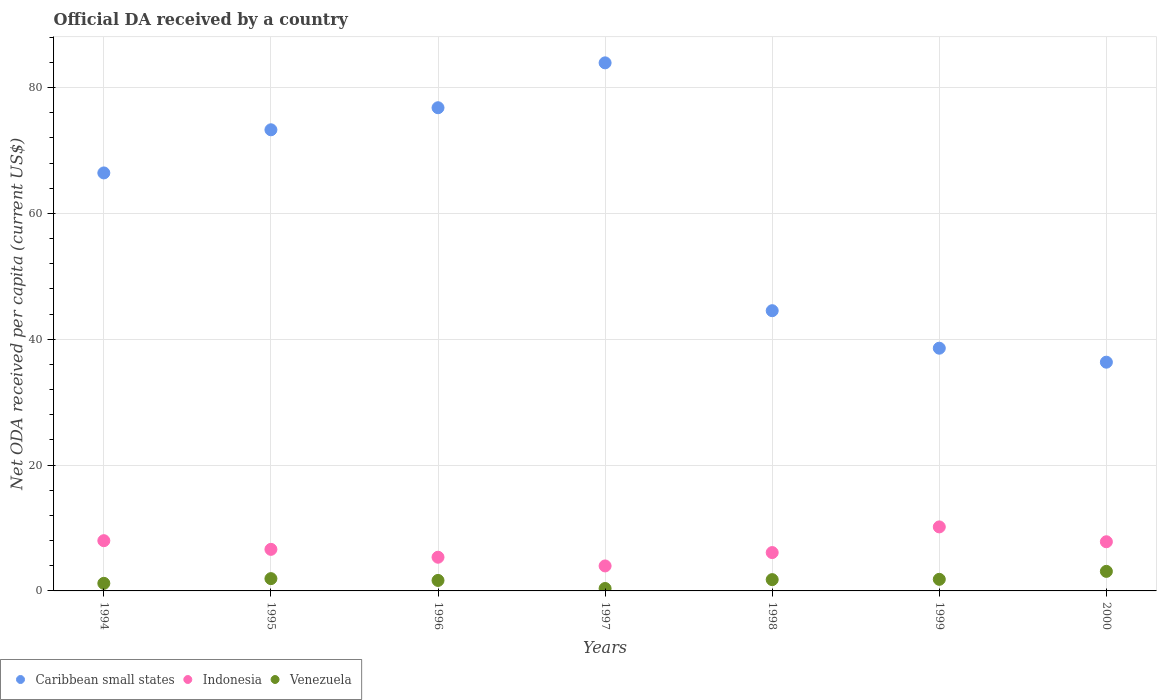What is the ODA received in in Caribbean small states in 1998?
Make the answer very short. 44.53. Across all years, what is the maximum ODA received in in Indonesia?
Make the answer very short. 10.17. Across all years, what is the minimum ODA received in in Venezuela?
Your answer should be very brief. 0.39. What is the total ODA received in in Venezuela in the graph?
Offer a very short reply. 11.95. What is the difference between the ODA received in in Caribbean small states in 1995 and that in 1998?
Your answer should be very brief. 28.75. What is the difference between the ODA received in in Indonesia in 1998 and the ODA received in in Caribbean small states in 1996?
Offer a very short reply. -70.69. What is the average ODA received in in Venezuela per year?
Give a very brief answer. 1.71. In the year 1996, what is the difference between the ODA received in in Indonesia and ODA received in in Caribbean small states?
Ensure brevity in your answer.  -71.43. What is the ratio of the ODA received in in Venezuela in 1999 to that in 2000?
Your answer should be very brief. 0.59. Is the ODA received in in Venezuela in 1996 less than that in 1997?
Your response must be concise. No. What is the difference between the highest and the second highest ODA received in in Venezuela?
Your answer should be compact. 1.15. What is the difference between the highest and the lowest ODA received in in Caribbean small states?
Provide a short and direct response. 47.57. Does the ODA received in in Caribbean small states monotonically increase over the years?
Your response must be concise. No. Is the ODA received in in Indonesia strictly greater than the ODA received in in Venezuela over the years?
Offer a very short reply. Yes. Is the ODA received in in Caribbean small states strictly less than the ODA received in in Indonesia over the years?
Your response must be concise. No. How many dotlines are there?
Your answer should be very brief. 3. Does the graph contain any zero values?
Offer a very short reply. No. How are the legend labels stacked?
Offer a terse response. Horizontal. What is the title of the graph?
Provide a short and direct response. Official DA received by a country. What is the label or title of the X-axis?
Provide a succinct answer. Years. What is the label or title of the Y-axis?
Your response must be concise. Net ODA received per capita (current US$). What is the Net ODA received per capita (current US$) of Caribbean small states in 1994?
Provide a succinct answer. 66.43. What is the Net ODA received per capita (current US$) in Indonesia in 1994?
Provide a short and direct response. 7.98. What is the Net ODA received per capita (current US$) in Venezuela in 1994?
Keep it short and to the point. 1.21. What is the Net ODA received per capita (current US$) of Caribbean small states in 1995?
Offer a terse response. 73.28. What is the Net ODA received per capita (current US$) of Indonesia in 1995?
Your answer should be very brief. 6.61. What is the Net ODA received per capita (current US$) in Venezuela in 1995?
Your response must be concise. 1.95. What is the Net ODA received per capita (current US$) of Caribbean small states in 1996?
Offer a very short reply. 76.79. What is the Net ODA received per capita (current US$) of Indonesia in 1996?
Give a very brief answer. 5.36. What is the Net ODA received per capita (current US$) of Venezuela in 1996?
Provide a short and direct response. 1.67. What is the Net ODA received per capita (current US$) in Caribbean small states in 1997?
Keep it short and to the point. 83.92. What is the Net ODA received per capita (current US$) of Indonesia in 1997?
Your answer should be very brief. 3.97. What is the Net ODA received per capita (current US$) of Venezuela in 1997?
Give a very brief answer. 0.39. What is the Net ODA received per capita (current US$) of Caribbean small states in 1998?
Give a very brief answer. 44.53. What is the Net ODA received per capita (current US$) of Indonesia in 1998?
Offer a very short reply. 6.1. What is the Net ODA received per capita (current US$) in Venezuela in 1998?
Provide a short and direct response. 1.79. What is the Net ODA received per capita (current US$) of Caribbean small states in 1999?
Your answer should be very brief. 38.57. What is the Net ODA received per capita (current US$) in Indonesia in 1999?
Your answer should be very brief. 10.17. What is the Net ODA received per capita (current US$) in Venezuela in 1999?
Give a very brief answer. 1.84. What is the Net ODA received per capita (current US$) of Caribbean small states in 2000?
Offer a terse response. 36.35. What is the Net ODA received per capita (current US$) in Indonesia in 2000?
Provide a succinct answer. 7.81. What is the Net ODA received per capita (current US$) in Venezuela in 2000?
Give a very brief answer. 3.11. Across all years, what is the maximum Net ODA received per capita (current US$) of Caribbean small states?
Make the answer very short. 83.92. Across all years, what is the maximum Net ODA received per capita (current US$) of Indonesia?
Offer a very short reply. 10.17. Across all years, what is the maximum Net ODA received per capita (current US$) of Venezuela?
Ensure brevity in your answer.  3.11. Across all years, what is the minimum Net ODA received per capita (current US$) of Caribbean small states?
Provide a short and direct response. 36.35. Across all years, what is the minimum Net ODA received per capita (current US$) of Indonesia?
Offer a very short reply. 3.97. Across all years, what is the minimum Net ODA received per capita (current US$) of Venezuela?
Give a very brief answer. 0.39. What is the total Net ODA received per capita (current US$) in Caribbean small states in the graph?
Provide a succinct answer. 419.88. What is the total Net ODA received per capita (current US$) of Indonesia in the graph?
Your answer should be very brief. 48. What is the total Net ODA received per capita (current US$) of Venezuela in the graph?
Keep it short and to the point. 11.95. What is the difference between the Net ODA received per capita (current US$) in Caribbean small states in 1994 and that in 1995?
Provide a succinct answer. -6.86. What is the difference between the Net ODA received per capita (current US$) in Indonesia in 1994 and that in 1995?
Make the answer very short. 1.38. What is the difference between the Net ODA received per capita (current US$) of Venezuela in 1994 and that in 1995?
Give a very brief answer. -0.75. What is the difference between the Net ODA received per capita (current US$) of Caribbean small states in 1994 and that in 1996?
Ensure brevity in your answer.  -10.36. What is the difference between the Net ODA received per capita (current US$) of Indonesia in 1994 and that in 1996?
Offer a very short reply. 2.63. What is the difference between the Net ODA received per capita (current US$) of Venezuela in 1994 and that in 1996?
Your answer should be very brief. -0.46. What is the difference between the Net ODA received per capita (current US$) of Caribbean small states in 1994 and that in 1997?
Offer a terse response. -17.49. What is the difference between the Net ODA received per capita (current US$) of Indonesia in 1994 and that in 1997?
Make the answer very short. 4.01. What is the difference between the Net ODA received per capita (current US$) of Venezuela in 1994 and that in 1997?
Your answer should be compact. 0.82. What is the difference between the Net ODA received per capita (current US$) in Caribbean small states in 1994 and that in 1998?
Your answer should be very brief. 21.89. What is the difference between the Net ODA received per capita (current US$) of Indonesia in 1994 and that in 1998?
Your response must be concise. 1.89. What is the difference between the Net ODA received per capita (current US$) in Venezuela in 1994 and that in 1998?
Your response must be concise. -0.59. What is the difference between the Net ODA received per capita (current US$) in Caribbean small states in 1994 and that in 1999?
Ensure brevity in your answer.  27.85. What is the difference between the Net ODA received per capita (current US$) in Indonesia in 1994 and that in 1999?
Your response must be concise. -2.19. What is the difference between the Net ODA received per capita (current US$) in Venezuela in 1994 and that in 1999?
Make the answer very short. -0.64. What is the difference between the Net ODA received per capita (current US$) of Caribbean small states in 1994 and that in 2000?
Your answer should be very brief. 30.08. What is the difference between the Net ODA received per capita (current US$) of Indonesia in 1994 and that in 2000?
Make the answer very short. 0.17. What is the difference between the Net ODA received per capita (current US$) of Venezuela in 1994 and that in 2000?
Your answer should be compact. -1.9. What is the difference between the Net ODA received per capita (current US$) of Caribbean small states in 1995 and that in 1996?
Offer a very short reply. -3.5. What is the difference between the Net ODA received per capita (current US$) in Indonesia in 1995 and that in 1996?
Offer a very short reply. 1.25. What is the difference between the Net ODA received per capita (current US$) in Venezuela in 1995 and that in 1996?
Keep it short and to the point. 0.28. What is the difference between the Net ODA received per capita (current US$) of Caribbean small states in 1995 and that in 1997?
Provide a short and direct response. -10.64. What is the difference between the Net ODA received per capita (current US$) in Indonesia in 1995 and that in 1997?
Give a very brief answer. 2.64. What is the difference between the Net ODA received per capita (current US$) of Venezuela in 1995 and that in 1997?
Your answer should be compact. 1.57. What is the difference between the Net ODA received per capita (current US$) in Caribbean small states in 1995 and that in 1998?
Your answer should be very brief. 28.75. What is the difference between the Net ODA received per capita (current US$) of Indonesia in 1995 and that in 1998?
Your response must be concise. 0.51. What is the difference between the Net ODA received per capita (current US$) in Venezuela in 1995 and that in 1998?
Give a very brief answer. 0.16. What is the difference between the Net ODA received per capita (current US$) of Caribbean small states in 1995 and that in 1999?
Offer a terse response. 34.71. What is the difference between the Net ODA received per capita (current US$) of Indonesia in 1995 and that in 1999?
Your answer should be very brief. -3.57. What is the difference between the Net ODA received per capita (current US$) in Venezuela in 1995 and that in 1999?
Provide a short and direct response. 0.11. What is the difference between the Net ODA received per capita (current US$) in Caribbean small states in 1995 and that in 2000?
Your response must be concise. 36.93. What is the difference between the Net ODA received per capita (current US$) of Indonesia in 1995 and that in 2000?
Your answer should be very brief. -1.21. What is the difference between the Net ODA received per capita (current US$) in Venezuela in 1995 and that in 2000?
Your answer should be very brief. -1.15. What is the difference between the Net ODA received per capita (current US$) of Caribbean small states in 1996 and that in 1997?
Provide a short and direct response. -7.13. What is the difference between the Net ODA received per capita (current US$) in Indonesia in 1996 and that in 1997?
Your answer should be very brief. 1.38. What is the difference between the Net ODA received per capita (current US$) in Venezuela in 1996 and that in 1997?
Keep it short and to the point. 1.28. What is the difference between the Net ODA received per capita (current US$) of Caribbean small states in 1996 and that in 1998?
Your answer should be very brief. 32.26. What is the difference between the Net ODA received per capita (current US$) of Indonesia in 1996 and that in 1998?
Your response must be concise. -0.74. What is the difference between the Net ODA received per capita (current US$) of Venezuela in 1996 and that in 1998?
Provide a short and direct response. -0.13. What is the difference between the Net ODA received per capita (current US$) in Caribbean small states in 1996 and that in 1999?
Your response must be concise. 38.21. What is the difference between the Net ODA received per capita (current US$) of Indonesia in 1996 and that in 1999?
Your answer should be very brief. -4.82. What is the difference between the Net ODA received per capita (current US$) of Venezuela in 1996 and that in 1999?
Make the answer very short. -0.17. What is the difference between the Net ODA received per capita (current US$) in Caribbean small states in 1996 and that in 2000?
Provide a succinct answer. 40.44. What is the difference between the Net ODA received per capita (current US$) in Indonesia in 1996 and that in 2000?
Your answer should be compact. -2.46. What is the difference between the Net ODA received per capita (current US$) in Venezuela in 1996 and that in 2000?
Offer a very short reply. -1.44. What is the difference between the Net ODA received per capita (current US$) in Caribbean small states in 1997 and that in 1998?
Provide a short and direct response. 39.39. What is the difference between the Net ODA received per capita (current US$) in Indonesia in 1997 and that in 1998?
Provide a short and direct response. -2.12. What is the difference between the Net ODA received per capita (current US$) of Venezuela in 1997 and that in 1998?
Offer a terse response. -1.41. What is the difference between the Net ODA received per capita (current US$) in Caribbean small states in 1997 and that in 1999?
Provide a succinct answer. 45.35. What is the difference between the Net ODA received per capita (current US$) in Indonesia in 1997 and that in 1999?
Offer a terse response. -6.2. What is the difference between the Net ODA received per capita (current US$) of Venezuela in 1997 and that in 1999?
Offer a terse response. -1.46. What is the difference between the Net ODA received per capita (current US$) of Caribbean small states in 1997 and that in 2000?
Your answer should be compact. 47.57. What is the difference between the Net ODA received per capita (current US$) of Indonesia in 1997 and that in 2000?
Ensure brevity in your answer.  -3.84. What is the difference between the Net ODA received per capita (current US$) of Venezuela in 1997 and that in 2000?
Ensure brevity in your answer.  -2.72. What is the difference between the Net ODA received per capita (current US$) of Caribbean small states in 1998 and that in 1999?
Your response must be concise. 5.96. What is the difference between the Net ODA received per capita (current US$) in Indonesia in 1998 and that in 1999?
Your answer should be compact. -4.08. What is the difference between the Net ODA received per capita (current US$) in Venezuela in 1998 and that in 1999?
Provide a short and direct response. -0.05. What is the difference between the Net ODA received per capita (current US$) in Caribbean small states in 1998 and that in 2000?
Provide a succinct answer. 8.18. What is the difference between the Net ODA received per capita (current US$) of Indonesia in 1998 and that in 2000?
Make the answer very short. -1.72. What is the difference between the Net ODA received per capita (current US$) of Venezuela in 1998 and that in 2000?
Your answer should be compact. -1.31. What is the difference between the Net ODA received per capita (current US$) of Caribbean small states in 1999 and that in 2000?
Ensure brevity in your answer.  2.22. What is the difference between the Net ODA received per capita (current US$) of Indonesia in 1999 and that in 2000?
Your answer should be compact. 2.36. What is the difference between the Net ODA received per capita (current US$) in Venezuela in 1999 and that in 2000?
Make the answer very short. -1.27. What is the difference between the Net ODA received per capita (current US$) in Caribbean small states in 1994 and the Net ODA received per capita (current US$) in Indonesia in 1995?
Offer a terse response. 59.82. What is the difference between the Net ODA received per capita (current US$) of Caribbean small states in 1994 and the Net ODA received per capita (current US$) of Venezuela in 1995?
Offer a terse response. 64.48. What is the difference between the Net ODA received per capita (current US$) in Indonesia in 1994 and the Net ODA received per capita (current US$) in Venezuela in 1995?
Provide a succinct answer. 6.03. What is the difference between the Net ODA received per capita (current US$) in Caribbean small states in 1994 and the Net ODA received per capita (current US$) in Indonesia in 1996?
Ensure brevity in your answer.  61.07. What is the difference between the Net ODA received per capita (current US$) in Caribbean small states in 1994 and the Net ODA received per capita (current US$) in Venezuela in 1996?
Make the answer very short. 64.76. What is the difference between the Net ODA received per capita (current US$) in Indonesia in 1994 and the Net ODA received per capita (current US$) in Venezuela in 1996?
Offer a very short reply. 6.32. What is the difference between the Net ODA received per capita (current US$) of Caribbean small states in 1994 and the Net ODA received per capita (current US$) of Indonesia in 1997?
Ensure brevity in your answer.  62.46. What is the difference between the Net ODA received per capita (current US$) in Caribbean small states in 1994 and the Net ODA received per capita (current US$) in Venezuela in 1997?
Offer a very short reply. 66.04. What is the difference between the Net ODA received per capita (current US$) in Indonesia in 1994 and the Net ODA received per capita (current US$) in Venezuela in 1997?
Your answer should be very brief. 7.6. What is the difference between the Net ODA received per capita (current US$) in Caribbean small states in 1994 and the Net ODA received per capita (current US$) in Indonesia in 1998?
Your answer should be compact. 60.33. What is the difference between the Net ODA received per capita (current US$) in Caribbean small states in 1994 and the Net ODA received per capita (current US$) in Venezuela in 1998?
Your answer should be very brief. 64.63. What is the difference between the Net ODA received per capita (current US$) in Indonesia in 1994 and the Net ODA received per capita (current US$) in Venezuela in 1998?
Provide a short and direct response. 6.19. What is the difference between the Net ODA received per capita (current US$) of Caribbean small states in 1994 and the Net ODA received per capita (current US$) of Indonesia in 1999?
Keep it short and to the point. 56.25. What is the difference between the Net ODA received per capita (current US$) in Caribbean small states in 1994 and the Net ODA received per capita (current US$) in Venezuela in 1999?
Your answer should be very brief. 64.59. What is the difference between the Net ODA received per capita (current US$) in Indonesia in 1994 and the Net ODA received per capita (current US$) in Venezuela in 1999?
Keep it short and to the point. 6.14. What is the difference between the Net ODA received per capita (current US$) of Caribbean small states in 1994 and the Net ODA received per capita (current US$) of Indonesia in 2000?
Offer a terse response. 58.61. What is the difference between the Net ODA received per capita (current US$) of Caribbean small states in 1994 and the Net ODA received per capita (current US$) of Venezuela in 2000?
Provide a succinct answer. 63.32. What is the difference between the Net ODA received per capita (current US$) of Indonesia in 1994 and the Net ODA received per capita (current US$) of Venezuela in 2000?
Make the answer very short. 4.88. What is the difference between the Net ODA received per capita (current US$) of Caribbean small states in 1995 and the Net ODA received per capita (current US$) of Indonesia in 1996?
Ensure brevity in your answer.  67.93. What is the difference between the Net ODA received per capita (current US$) in Caribbean small states in 1995 and the Net ODA received per capita (current US$) in Venezuela in 1996?
Make the answer very short. 71.62. What is the difference between the Net ODA received per capita (current US$) in Indonesia in 1995 and the Net ODA received per capita (current US$) in Venezuela in 1996?
Offer a very short reply. 4.94. What is the difference between the Net ODA received per capita (current US$) of Caribbean small states in 1995 and the Net ODA received per capita (current US$) of Indonesia in 1997?
Your response must be concise. 69.31. What is the difference between the Net ODA received per capita (current US$) in Caribbean small states in 1995 and the Net ODA received per capita (current US$) in Venezuela in 1997?
Keep it short and to the point. 72.9. What is the difference between the Net ODA received per capita (current US$) in Indonesia in 1995 and the Net ODA received per capita (current US$) in Venezuela in 1997?
Offer a very short reply. 6.22. What is the difference between the Net ODA received per capita (current US$) in Caribbean small states in 1995 and the Net ODA received per capita (current US$) in Indonesia in 1998?
Keep it short and to the point. 67.19. What is the difference between the Net ODA received per capita (current US$) in Caribbean small states in 1995 and the Net ODA received per capita (current US$) in Venezuela in 1998?
Provide a succinct answer. 71.49. What is the difference between the Net ODA received per capita (current US$) in Indonesia in 1995 and the Net ODA received per capita (current US$) in Venezuela in 1998?
Ensure brevity in your answer.  4.81. What is the difference between the Net ODA received per capita (current US$) in Caribbean small states in 1995 and the Net ODA received per capita (current US$) in Indonesia in 1999?
Make the answer very short. 63.11. What is the difference between the Net ODA received per capita (current US$) of Caribbean small states in 1995 and the Net ODA received per capita (current US$) of Venezuela in 1999?
Offer a terse response. 71.44. What is the difference between the Net ODA received per capita (current US$) in Indonesia in 1995 and the Net ODA received per capita (current US$) in Venezuela in 1999?
Your answer should be compact. 4.77. What is the difference between the Net ODA received per capita (current US$) in Caribbean small states in 1995 and the Net ODA received per capita (current US$) in Indonesia in 2000?
Give a very brief answer. 65.47. What is the difference between the Net ODA received per capita (current US$) in Caribbean small states in 1995 and the Net ODA received per capita (current US$) in Venezuela in 2000?
Make the answer very short. 70.18. What is the difference between the Net ODA received per capita (current US$) in Indonesia in 1995 and the Net ODA received per capita (current US$) in Venezuela in 2000?
Provide a succinct answer. 3.5. What is the difference between the Net ODA received per capita (current US$) of Caribbean small states in 1996 and the Net ODA received per capita (current US$) of Indonesia in 1997?
Your answer should be very brief. 72.82. What is the difference between the Net ODA received per capita (current US$) of Caribbean small states in 1996 and the Net ODA received per capita (current US$) of Venezuela in 1997?
Give a very brief answer. 76.4. What is the difference between the Net ODA received per capita (current US$) in Indonesia in 1996 and the Net ODA received per capita (current US$) in Venezuela in 1997?
Your answer should be very brief. 4.97. What is the difference between the Net ODA received per capita (current US$) of Caribbean small states in 1996 and the Net ODA received per capita (current US$) of Indonesia in 1998?
Provide a short and direct response. 70.69. What is the difference between the Net ODA received per capita (current US$) of Caribbean small states in 1996 and the Net ODA received per capita (current US$) of Venezuela in 1998?
Offer a very short reply. 75. What is the difference between the Net ODA received per capita (current US$) of Indonesia in 1996 and the Net ODA received per capita (current US$) of Venezuela in 1998?
Ensure brevity in your answer.  3.56. What is the difference between the Net ODA received per capita (current US$) of Caribbean small states in 1996 and the Net ODA received per capita (current US$) of Indonesia in 1999?
Provide a succinct answer. 66.62. What is the difference between the Net ODA received per capita (current US$) of Caribbean small states in 1996 and the Net ODA received per capita (current US$) of Venezuela in 1999?
Your answer should be compact. 74.95. What is the difference between the Net ODA received per capita (current US$) of Indonesia in 1996 and the Net ODA received per capita (current US$) of Venezuela in 1999?
Give a very brief answer. 3.51. What is the difference between the Net ODA received per capita (current US$) in Caribbean small states in 1996 and the Net ODA received per capita (current US$) in Indonesia in 2000?
Provide a short and direct response. 68.98. What is the difference between the Net ODA received per capita (current US$) in Caribbean small states in 1996 and the Net ODA received per capita (current US$) in Venezuela in 2000?
Your answer should be compact. 73.68. What is the difference between the Net ODA received per capita (current US$) in Indonesia in 1996 and the Net ODA received per capita (current US$) in Venezuela in 2000?
Keep it short and to the point. 2.25. What is the difference between the Net ODA received per capita (current US$) of Caribbean small states in 1997 and the Net ODA received per capita (current US$) of Indonesia in 1998?
Offer a terse response. 77.83. What is the difference between the Net ODA received per capita (current US$) in Caribbean small states in 1997 and the Net ODA received per capita (current US$) in Venezuela in 1998?
Offer a terse response. 82.13. What is the difference between the Net ODA received per capita (current US$) of Indonesia in 1997 and the Net ODA received per capita (current US$) of Venezuela in 1998?
Ensure brevity in your answer.  2.18. What is the difference between the Net ODA received per capita (current US$) of Caribbean small states in 1997 and the Net ODA received per capita (current US$) of Indonesia in 1999?
Make the answer very short. 73.75. What is the difference between the Net ODA received per capita (current US$) in Caribbean small states in 1997 and the Net ODA received per capita (current US$) in Venezuela in 1999?
Make the answer very short. 82.08. What is the difference between the Net ODA received per capita (current US$) in Indonesia in 1997 and the Net ODA received per capita (current US$) in Venezuela in 1999?
Give a very brief answer. 2.13. What is the difference between the Net ODA received per capita (current US$) of Caribbean small states in 1997 and the Net ODA received per capita (current US$) of Indonesia in 2000?
Offer a terse response. 76.11. What is the difference between the Net ODA received per capita (current US$) of Caribbean small states in 1997 and the Net ODA received per capita (current US$) of Venezuela in 2000?
Provide a succinct answer. 80.81. What is the difference between the Net ODA received per capita (current US$) of Indonesia in 1997 and the Net ODA received per capita (current US$) of Venezuela in 2000?
Give a very brief answer. 0.86. What is the difference between the Net ODA received per capita (current US$) in Caribbean small states in 1998 and the Net ODA received per capita (current US$) in Indonesia in 1999?
Make the answer very short. 34.36. What is the difference between the Net ODA received per capita (current US$) in Caribbean small states in 1998 and the Net ODA received per capita (current US$) in Venezuela in 1999?
Your response must be concise. 42.69. What is the difference between the Net ODA received per capita (current US$) in Indonesia in 1998 and the Net ODA received per capita (current US$) in Venezuela in 1999?
Your response must be concise. 4.25. What is the difference between the Net ODA received per capita (current US$) of Caribbean small states in 1998 and the Net ODA received per capita (current US$) of Indonesia in 2000?
Make the answer very short. 36.72. What is the difference between the Net ODA received per capita (current US$) in Caribbean small states in 1998 and the Net ODA received per capita (current US$) in Venezuela in 2000?
Make the answer very short. 41.43. What is the difference between the Net ODA received per capita (current US$) of Indonesia in 1998 and the Net ODA received per capita (current US$) of Venezuela in 2000?
Ensure brevity in your answer.  2.99. What is the difference between the Net ODA received per capita (current US$) of Caribbean small states in 1999 and the Net ODA received per capita (current US$) of Indonesia in 2000?
Your answer should be compact. 30.76. What is the difference between the Net ODA received per capita (current US$) in Caribbean small states in 1999 and the Net ODA received per capita (current US$) in Venezuela in 2000?
Your answer should be compact. 35.47. What is the difference between the Net ODA received per capita (current US$) of Indonesia in 1999 and the Net ODA received per capita (current US$) of Venezuela in 2000?
Your answer should be compact. 7.07. What is the average Net ODA received per capita (current US$) of Caribbean small states per year?
Your answer should be very brief. 59.98. What is the average Net ODA received per capita (current US$) of Indonesia per year?
Make the answer very short. 6.86. What is the average Net ODA received per capita (current US$) in Venezuela per year?
Keep it short and to the point. 1.71. In the year 1994, what is the difference between the Net ODA received per capita (current US$) in Caribbean small states and Net ODA received per capita (current US$) in Indonesia?
Your answer should be compact. 58.44. In the year 1994, what is the difference between the Net ODA received per capita (current US$) of Caribbean small states and Net ODA received per capita (current US$) of Venezuela?
Your response must be concise. 65.22. In the year 1994, what is the difference between the Net ODA received per capita (current US$) of Indonesia and Net ODA received per capita (current US$) of Venezuela?
Keep it short and to the point. 6.78. In the year 1995, what is the difference between the Net ODA received per capita (current US$) in Caribbean small states and Net ODA received per capita (current US$) in Indonesia?
Provide a succinct answer. 66.68. In the year 1995, what is the difference between the Net ODA received per capita (current US$) of Caribbean small states and Net ODA received per capita (current US$) of Venezuela?
Your response must be concise. 71.33. In the year 1995, what is the difference between the Net ODA received per capita (current US$) of Indonesia and Net ODA received per capita (current US$) of Venezuela?
Your response must be concise. 4.65. In the year 1996, what is the difference between the Net ODA received per capita (current US$) in Caribbean small states and Net ODA received per capita (current US$) in Indonesia?
Your answer should be very brief. 71.43. In the year 1996, what is the difference between the Net ODA received per capita (current US$) in Caribbean small states and Net ODA received per capita (current US$) in Venezuela?
Ensure brevity in your answer.  75.12. In the year 1996, what is the difference between the Net ODA received per capita (current US$) of Indonesia and Net ODA received per capita (current US$) of Venezuela?
Offer a very short reply. 3.69. In the year 1997, what is the difference between the Net ODA received per capita (current US$) in Caribbean small states and Net ODA received per capita (current US$) in Indonesia?
Keep it short and to the point. 79.95. In the year 1997, what is the difference between the Net ODA received per capita (current US$) in Caribbean small states and Net ODA received per capita (current US$) in Venezuela?
Give a very brief answer. 83.54. In the year 1997, what is the difference between the Net ODA received per capita (current US$) of Indonesia and Net ODA received per capita (current US$) of Venezuela?
Your answer should be very brief. 3.58. In the year 1998, what is the difference between the Net ODA received per capita (current US$) of Caribbean small states and Net ODA received per capita (current US$) of Indonesia?
Offer a very short reply. 38.44. In the year 1998, what is the difference between the Net ODA received per capita (current US$) of Caribbean small states and Net ODA received per capita (current US$) of Venezuela?
Ensure brevity in your answer.  42.74. In the year 1998, what is the difference between the Net ODA received per capita (current US$) in Indonesia and Net ODA received per capita (current US$) in Venezuela?
Give a very brief answer. 4.3. In the year 1999, what is the difference between the Net ODA received per capita (current US$) in Caribbean small states and Net ODA received per capita (current US$) in Indonesia?
Your answer should be very brief. 28.4. In the year 1999, what is the difference between the Net ODA received per capita (current US$) in Caribbean small states and Net ODA received per capita (current US$) in Venezuela?
Make the answer very short. 36.73. In the year 1999, what is the difference between the Net ODA received per capita (current US$) in Indonesia and Net ODA received per capita (current US$) in Venezuela?
Your answer should be compact. 8.33. In the year 2000, what is the difference between the Net ODA received per capita (current US$) in Caribbean small states and Net ODA received per capita (current US$) in Indonesia?
Give a very brief answer. 28.54. In the year 2000, what is the difference between the Net ODA received per capita (current US$) in Caribbean small states and Net ODA received per capita (current US$) in Venezuela?
Your answer should be very brief. 33.24. In the year 2000, what is the difference between the Net ODA received per capita (current US$) in Indonesia and Net ODA received per capita (current US$) in Venezuela?
Provide a succinct answer. 4.71. What is the ratio of the Net ODA received per capita (current US$) of Caribbean small states in 1994 to that in 1995?
Ensure brevity in your answer.  0.91. What is the ratio of the Net ODA received per capita (current US$) of Indonesia in 1994 to that in 1995?
Make the answer very short. 1.21. What is the ratio of the Net ODA received per capita (current US$) of Venezuela in 1994 to that in 1995?
Keep it short and to the point. 0.62. What is the ratio of the Net ODA received per capita (current US$) in Caribbean small states in 1994 to that in 1996?
Offer a very short reply. 0.87. What is the ratio of the Net ODA received per capita (current US$) of Indonesia in 1994 to that in 1996?
Give a very brief answer. 1.49. What is the ratio of the Net ODA received per capita (current US$) in Venezuela in 1994 to that in 1996?
Offer a terse response. 0.72. What is the ratio of the Net ODA received per capita (current US$) of Caribbean small states in 1994 to that in 1997?
Your answer should be very brief. 0.79. What is the ratio of the Net ODA received per capita (current US$) of Indonesia in 1994 to that in 1997?
Make the answer very short. 2.01. What is the ratio of the Net ODA received per capita (current US$) of Venezuela in 1994 to that in 1997?
Offer a very short reply. 3.12. What is the ratio of the Net ODA received per capita (current US$) in Caribbean small states in 1994 to that in 1998?
Provide a succinct answer. 1.49. What is the ratio of the Net ODA received per capita (current US$) in Indonesia in 1994 to that in 1998?
Your answer should be compact. 1.31. What is the ratio of the Net ODA received per capita (current US$) of Venezuela in 1994 to that in 1998?
Provide a short and direct response. 0.67. What is the ratio of the Net ODA received per capita (current US$) in Caribbean small states in 1994 to that in 1999?
Provide a succinct answer. 1.72. What is the ratio of the Net ODA received per capita (current US$) of Indonesia in 1994 to that in 1999?
Give a very brief answer. 0.78. What is the ratio of the Net ODA received per capita (current US$) in Venezuela in 1994 to that in 1999?
Keep it short and to the point. 0.66. What is the ratio of the Net ODA received per capita (current US$) in Caribbean small states in 1994 to that in 2000?
Provide a short and direct response. 1.83. What is the ratio of the Net ODA received per capita (current US$) in Indonesia in 1994 to that in 2000?
Offer a terse response. 1.02. What is the ratio of the Net ODA received per capita (current US$) in Venezuela in 1994 to that in 2000?
Offer a very short reply. 0.39. What is the ratio of the Net ODA received per capita (current US$) of Caribbean small states in 1995 to that in 1996?
Provide a succinct answer. 0.95. What is the ratio of the Net ODA received per capita (current US$) of Indonesia in 1995 to that in 1996?
Offer a terse response. 1.23. What is the ratio of the Net ODA received per capita (current US$) in Venezuela in 1995 to that in 1996?
Provide a short and direct response. 1.17. What is the ratio of the Net ODA received per capita (current US$) of Caribbean small states in 1995 to that in 1997?
Ensure brevity in your answer.  0.87. What is the ratio of the Net ODA received per capita (current US$) of Indonesia in 1995 to that in 1997?
Keep it short and to the point. 1.66. What is the ratio of the Net ODA received per capita (current US$) of Venezuela in 1995 to that in 1997?
Make the answer very short. 5.06. What is the ratio of the Net ODA received per capita (current US$) of Caribbean small states in 1995 to that in 1998?
Give a very brief answer. 1.65. What is the ratio of the Net ODA received per capita (current US$) in Indonesia in 1995 to that in 1998?
Your response must be concise. 1.08. What is the ratio of the Net ODA received per capita (current US$) in Venezuela in 1995 to that in 1998?
Give a very brief answer. 1.09. What is the ratio of the Net ODA received per capita (current US$) in Caribbean small states in 1995 to that in 1999?
Your answer should be very brief. 1.9. What is the ratio of the Net ODA received per capita (current US$) of Indonesia in 1995 to that in 1999?
Provide a short and direct response. 0.65. What is the ratio of the Net ODA received per capita (current US$) of Venezuela in 1995 to that in 1999?
Provide a short and direct response. 1.06. What is the ratio of the Net ODA received per capita (current US$) in Caribbean small states in 1995 to that in 2000?
Keep it short and to the point. 2.02. What is the ratio of the Net ODA received per capita (current US$) of Indonesia in 1995 to that in 2000?
Make the answer very short. 0.85. What is the ratio of the Net ODA received per capita (current US$) in Venezuela in 1995 to that in 2000?
Make the answer very short. 0.63. What is the ratio of the Net ODA received per capita (current US$) of Caribbean small states in 1996 to that in 1997?
Offer a very short reply. 0.92. What is the ratio of the Net ODA received per capita (current US$) in Indonesia in 1996 to that in 1997?
Make the answer very short. 1.35. What is the ratio of the Net ODA received per capita (current US$) in Venezuela in 1996 to that in 1997?
Ensure brevity in your answer.  4.32. What is the ratio of the Net ODA received per capita (current US$) in Caribbean small states in 1996 to that in 1998?
Provide a succinct answer. 1.72. What is the ratio of the Net ODA received per capita (current US$) of Indonesia in 1996 to that in 1998?
Give a very brief answer. 0.88. What is the ratio of the Net ODA received per capita (current US$) in Venezuela in 1996 to that in 1998?
Your answer should be compact. 0.93. What is the ratio of the Net ODA received per capita (current US$) of Caribbean small states in 1996 to that in 1999?
Ensure brevity in your answer.  1.99. What is the ratio of the Net ODA received per capita (current US$) of Indonesia in 1996 to that in 1999?
Your answer should be compact. 0.53. What is the ratio of the Net ODA received per capita (current US$) in Venezuela in 1996 to that in 1999?
Your response must be concise. 0.91. What is the ratio of the Net ODA received per capita (current US$) of Caribbean small states in 1996 to that in 2000?
Provide a succinct answer. 2.11. What is the ratio of the Net ODA received per capita (current US$) in Indonesia in 1996 to that in 2000?
Make the answer very short. 0.69. What is the ratio of the Net ODA received per capita (current US$) in Venezuela in 1996 to that in 2000?
Your response must be concise. 0.54. What is the ratio of the Net ODA received per capita (current US$) of Caribbean small states in 1997 to that in 1998?
Your answer should be very brief. 1.88. What is the ratio of the Net ODA received per capita (current US$) in Indonesia in 1997 to that in 1998?
Provide a short and direct response. 0.65. What is the ratio of the Net ODA received per capita (current US$) in Venezuela in 1997 to that in 1998?
Offer a very short reply. 0.22. What is the ratio of the Net ODA received per capita (current US$) in Caribbean small states in 1997 to that in 1999?
Give a very brief answer. 2.18. What is the ratio of the Net ODA received per capita (current US$) of Indonesia in 1997 to that in 1999?
Your answer should be very brief. 0.39. What is the ratio of the Net ODA received per capita (current US$) of Venezuela in 1997 to that in 1999?
Your response must be concise. 0.21. What is the ratio of the Net ODA received per capita (current US$) in Caribbean small states in 1997 to that in 2000?
Keep it short and to the point. 2.31. What is the ratio of the Net ODA received per capita (current US$) of Indonesia in 1997 to that in 2000?
Your response must be concise. 0.51. What is the ratio of the Net ODA received per capita (current US$) of Venezuela in 1997 to that in 2000?
Your answer should be compact. 0.12. What is the ratio of the Net ODA received per capita (current US$) in Caribbean small states in 1998 to that in 1999?
Make the answer very short. 1.15. What is the ratio of the Net ODA received per capita (current US$) of Indonesia in 1998 to that in 1999?
Provide a succinct answer. 0.6. What is the ratio of the Net ODA received per capita (current US$) in Venezuela in 1998 to that in 1999?
Your answer should be compact. 0.97. What is the ratio of the Net ODA received per capita (current US$) of Caribbean small states in 1998 to that in 2000?
Offer a terse response. 1.23. What is the ratio of the Net ODA received per capita (current US$) in Indonesia in 1998 to that in 2000?
Provide a succinct answer. 0.78. What is the ratio of the Net ODA received per capita (current US$) in Venezuela in 1998 to that in 2000?
Offer a very short reply. 0.58. What is the ratio of the Net ODA received per capita (current US$) in Caribbean small states in 1999 to that in 2000?
Ensure brevity in your answer.  1.06. What is the ratio of the Net ODA received per capita (current US$) of Indonesia in 1999 to that in 2000?
Your response must be concise. 1.3. What is the ratio of the Net ODA received per capita (current US$) of Venezuela in 1999 to that in 2000?
Make the answer very short. 0.59. What is the difference between the highest and the second highest Net ODA received per capita (current US$) of Caribbean small states?
Give a very brief answer. 7.13. What is the difference between the highest and the second highest Net ODA received per capita (current US$) in Indonesia?
Give a very brief answer. 2.19. What is the difference between the highest and the second highest Net ODA received per capita (current US$) of Venezuela?
Provide a succinct answer. 1.15. What is the difference between the highest and the lowest Net ODA received per capita (current US$) of Caribbean small states?
Your response must be concise. 47.57. What is the difference between the highest and the lowest Net ODA received per capita (current US$) of Indonesia?
Offer a very short reply. 6.2. What is the difference between the highest and the lowest Net ODA received per capita (current US$) of Venezuela?
Your answer should be compact. 2.72. 